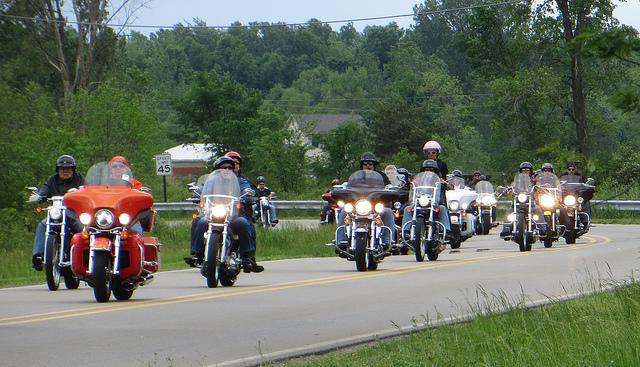What are the people doing with their motorcycles?

Choices:
A) parading
B) protesting
C) looting
D) racing parading 